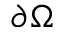<formula> <loc_0><loc_0><loc_500><loc_500>\partial \Omega</formula> 